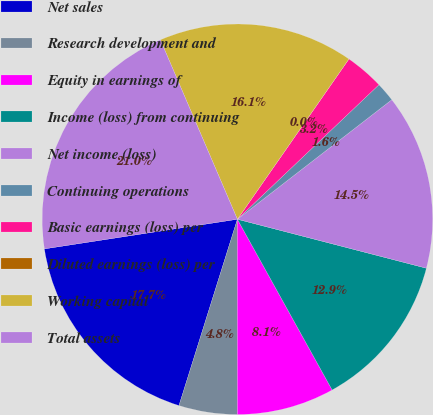Convert chart to OTSL. <chart><loc_0><loc_0><loc_500><loc_500><pie_chart><fcel>Net sales<fcel>Research development and<fcel>Equity in earnings of<fcel>Income (loss) from continuing<fcel>Net income (loss)<fcel>Continuing operations<fcel>Basic earnings (loss) per<fcel>Diluted earnings (loss) per<fcel>Working capital<fcel>Total assets<nl><fcel>17.74%<fcel>4.84%<fcel>8.06%<fcel>12.9%<fcel>14.52%<fcel>1.61%<fcel>3.23%<fcel>0.0%<fcel>16.13%<fcel>20.97%<nl></chart> 